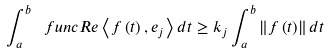<formula> <loc_0><loc_0><loc_500><loc_500>\int _ { a } ^ { b } \ f u n c { R e } \left \langle f \left ( t \right ) , e _ { j } \right \rangle d t \geq k _ { j } \int _ { a } ^ { b } \left \| f \left ( t \right ) \right \| d t</formula> 